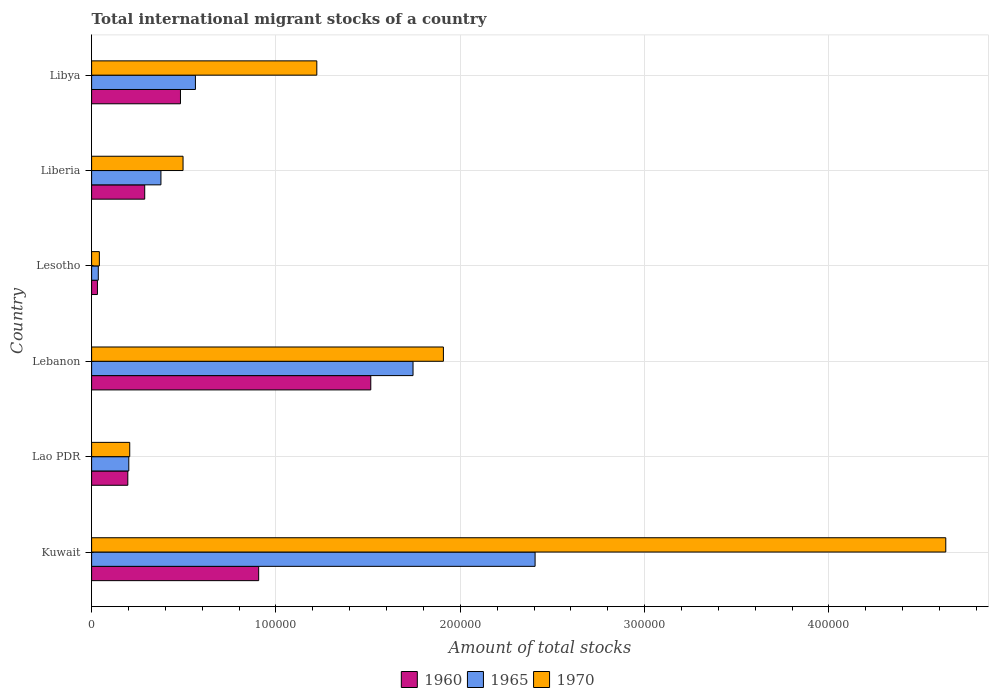How many bars are there on the 6th tick from the bottom?
Your answer should be compact. 3. What is the label of the 4th group of bars from the top?
Your response must be concise. Lebanon. What is the amount of total stocks in in 1965 in Liberia?
Give a very brief answer. 3.76e+04. Across all countries, what is the maximum amount of total stocks in in 1965?
Offer a terse response. 2.41e+05. Across all countries, what is the minimum amount of total stocks in in 1970?
Your answer should be very brief. 4205. In which country was the amount of total stocks in in 1960 maximum?
Your answer should be compact. Lebanon. In which country was the amount of total stocks in in 1960 minimum?
Give a very brief answer. Lesotho. What is the total amount of total stocks in in 1965 in the graph?
Offer a terse response. 5.33e+05. What is the difference between the amount of total stocks in in 1960 in Kuwait and that in Libya?
Your answer should be very brief. 4.24e+04. What is the difference between the amount of total stocks in in 1970 in Lesotho and the amount of total stocks in in 1960 in Kuwait?
Give a very brief answer. -8.64e+04. What is the average amount of total stocks in in 1965 per country?
Offer a terse response. 8.88e+04. What is the difference between the amount of total stocks in in 1960 and amount of total stocks in in 1965 in Lebanon?
Your response must be concise. -2.29e+04. In how many countries, is the amount of total stocks in in 1970 greater than 340000 ?
Make the answer very short. 1. What is the ratio of the amount of total stocks in in 1960 in Lebanon to that in Liberia?
Offer a very short reply. 5.26. Is the amount of total stocks in in 1965 in Lao PDR less than that in Lebanon?
Give a very brief answer. Yes. Is the difference between the amount of total stocks in in 1960 in Lao PDR and Lesotho greater than the difference between the amount of total stocks in in 1965 in Lao PDR and Lesotho?
Offer a very short reply. No. What is the difference between the highest and the second highest amount of total stocks in in 1970?
Your answer should be compact. 2.73e+05. What is the difference between the highest and the lowest amount of total stocks in in 1960?
Give a very brief answer. 1.48e+05. Is the sum of the amount of total stocks in in 1965 in Lao PDR and Liberia greater than the maximum amount of total stocks in in 1970 across all countries?
Give a very brief answer. No. What does the 1st bar from the top in Lao PDR represents?
Offer a terse response. 1970. What does the 1st bar from the bottom in Kuwait represents?
Offer a very short reply. 1960. Are all the bars in the graph horizontal?
Give a very brief answer. Yes. How many countries are there in the graph?
Provide a short and direct response. 6. Are the values on the major ticks of X-axis written in scientific E-notation?
Provide a succinct answer. No. Does the graph contain any zero values?
Offer a terse response. No. Does the graph contain grids?
Your answer should be very brief. Yes. Where does the legend appear in the graph?
Your answer should be compact. Bottom center. How many legend labels are there?
Keep it short and to the point. 3. What is the title of the graph?
Offer a very short reply. Total international migrant stocks of a country. What is the label or title of the X-axis?
Offer a very short reply. Amount of total stocks. What is the Amount of total stocks of 1960 in Kuwait?
Offer a very short reply. 9.06e+04. What is the Amount of total stocks of 1965 in Kuwait?
Your response must be concise. 2.41e+05. What is the Amount of total stocks in 1970 in Kuwait?
Your answer should be very brief. 4.63e+05. What is the Amount of total stocks of 1960 in Lao PDR?
Offer a very short reply. 1.96e+04. What is the Amount of total stocks in 1965 in Lao PDR?
Your answer should be compact. 2.02e+04. What is the Amount of total stocks in 1970 in Lao PDR?
Your answer should be very brief. 2.07e+04. What is the Amount of total stocks of 1960 in Lebanon?
Keep it short and to the point. 1.51e+05. What is the Amount of total stocks of 1965 in Lebanon?
Offer a very short reply. 1.74e+05. What is the Amount of total stocks in 1970 in Lebanon?
Make the answer very short. 1.91e+05. What is the Amount of total stocks of 1960 in Lesotho?
Give a very brief answer. 3165. What is the Amount of total stocks of 1965 in Lesotho?
Make the answer very short. 3633. What is the Amount of total stocks in 1970 in Lesotho?
Offer a terse response. 4205. What is the Amount of total stocks of 1960 in Liberia?
Offer a terse response. 2.88e+04. What is the Amount of total stocks of 1965 in Liberia?
Your response must be concise. 3.76e+04. What is the Amount of total stocks in 1970 in Liberia?
Give a very brief answer. 4.96e+04. What is the Amount of total stocks in 1960 in Libya?
Provide a succinct answer. 4.82e+04. What is the Amount of total stocks of 1965 in Libya?
Your answer should be compact. 5.63e+04. What is the Amount of total stocks of 1970 in Libya?
Your response must be concise. 1.22e+05. Across all countries, what is the maximum Amount of total stocks in 1960?
Make the answer very short. 1.51e+05. Across all countries, what is the maximum Amount of total stocks in 1965?
Offer a terse response. 2.41e+05. Across all countries, what is the maximum Amount of total stocks of 1970?
Provide a succinct answer. 4.63e+05. Across all countries, what is the minimum Amount of total stocks of 1960?
Provide a short and direct response. 3165. Across all countries, what is the minimum Amount of total stocks in 1965?
Provide a succinct answer. 3633. Across all countries, what is the minimum Amount of total stocks of 1970?
Ensure brevity in your answer.  4205. What is the total Amount of total stocks of 1960 in the graph?
Make the answer very short. 3.42e+05. What is the total Amount of total stocks in 1965 in the graph?
Offer a terse response. 5.33e+05. What is the total Amount of total stocks of 1970 in the graph?
Ensure brevity in your answer.  8.51e+05. What is the difference between the Amount of total stocks in 1960 in Kuwait and that in Lao PDR?
Your answer should be very brief. 7.10e+04. What is the difference between the Amount of total stocks in 1965 in Kuwait and that in Lao PDR?
Provide a short and direct response. 2.20e+05. What is the difference between the Amount of total stocks in 1970 in Kuwait and that in Lao PDR?
Your response must be concise. 4.43e+05. What is the difference between the Amount of total stocks in 1960 in Kuwait and that in Lebanon?
Make the answer very short. -6.08e+04. What is the difference between the Amount of total stocks of 1965 in Kuwait and that in Lebanon?
Make the answer very short. 6.62e+04. What is the difference between the Amount of total stocks in 1970 in Kuwait and that in Lebanon?
Offer a terse response. 2.73e+05. What is the difference between the Amount of total stocks in 1960 in Kuwait and that in Lesotho?
Provide a short and direct response. 8.75e+04. What is the difference between the Amount of total stocks of 1965 in Kuwait and that in Lesotho?
Your answer should be compact. 2.37e+05. What is the difference between the Amount of total stocks of 1970 in Kuwait and that in Lesotho?
Your response must be concise. 4.59e+05. What is the difference between the Amount of total stocks of 1960 in Kuwait and that in Liberia?
Give a very brief answer. 6.18e+04. What is the difference between the Amount of total stocks in 1965 in Kuwait and that in Liberia?
Provide a succinct answer. 2.03e+05. What is the difference between the Amount of total stocks of 1970 in Kuwait and that in Liberia?
Offer a very short reply. 4.14e+05. What is the difference between the Amount of total stocks of 1960 in Kuwait and that in Libya?
Your answer should be very brief. 4.24e+04. What is the difference between the Amount of total stocks in 1965 in Kuwait and that in Libya?
Give a very brief answer. 1.84e+05. What is the difference between the Amount of total stocks in 1970 in Kuwait and that in Libya?
Your answer should be compact. 3.41e+05. What is the difference between the Amount of total stocks of 1960 in Lao PDR and that in Lebanon?
Keep it short and to the point. -1.32e+05. What is the difference between the Amount of total stocks of 1965 in Lao PDR and that in Lebanon?
Your answer should be compact. -1.54e+05. What is the difference between the Amount of total stocks of 1970 in Lao PDR and that in Lebanon?
Ensure brevity in your answer.  -1.70e+05. What is the difference between the Amount of total stocks of 1960 in Lao PDR and that in Lesotho?
Offer a terse response. 1.65e+04. What is the difference between the Amount of total stocks in 1965 in Lao PDR and that in Lesotho?
Ensure brevity in your answer.  1.65e+04. What is the difference between the Amount of total stocks of 1970 in Lao PDR and that in Lesotho?
Your response must be concise. 1.65e+04. What is the difference between the Amount of total stocks of 1960 in Lao PDR and that in Liberia?
Provide a succinct answer. -9165. What is the difference between the Amount of total stocks of 1965 in Lao PDR and that in Liberia?
Provide a short and direct response. -1.74e+04. What is the difference between the Amount of total stocks in 1970 in Lao PDR and that in Liberia?
Your answer should be compact. -2.89e+04. What is the difference between the Amount of total stocks of 1960 in Lao PDR and that in Libya?
Make the answer very short. -2.86e+04. What is the difference between the Amount of total stocks in 1965 in Lao PDR and that in Libya?
Your answer should be compact. -3.61e+04. What is the difference between the Amount of total stocks of 1970 in Lao PDR and that in Libya?
Make the answer very short. -1.01e+05. What is the difference between the Amount of total stocks of 1960 in Lebanon and that in Lesotho?
Ensure brevity in your answer.  1.48e+05. What is the difference between the Amount of total stocks in 1965 in Lebanon and that in Lesotho?
Provide a short and direct response. 1.71e+05. What is the difference between the Amount of total stocks of 1970 in Lebanon and that in Lesotho?
Make the answer very short. 1.87e+05. What is the difference between the Amount of total stocks of 1960 in Lebanon and that in Liberia?
Offer a very short reply. 1.23e+05. What is the difference between the Amount of total stocks in 1965 in Lebanon and that in Liberia?
Your response must be concise. 1.37e+05. What is the difference between the Amount of total stocks in 1970 in Lebanon and that in Liberia?
Your answer should be compact. 1.41e+05. What is the difference between the Amount of total stocks of 1960 in Lebanon and that in Libya?
Your answer should be very brief. 1.03e+05. What is the difference between the Amount of total stocks of 1965 in Lebanon and that in Libya?
Your answer should be very brief. 1.18e+05. What is the difference between the Amount of total stocks in 1970 in Lebanon and that in Libya?
Provide a short and direct response. 6.87e+04. What is the difference between the Amount of total stocks in 1960 in Lesotho and that in Liberia?
Offer a very short reply. -2.56e+04. What is the difference between the Amount of total stocks of 1965 in Lesotho and that in Liberia?
Your answer should be very brief. -3.40e+04. What is the difference between the Amount of total stocks in 1970 in Lesotho and that in Liberia?
Make the answer very short. -4.54e+04. What is the difference between the Amount of total stocks in 1960 in Lesotho and that in Libya?
Keep it short and to the point. -4.50e+04. What is the difference between the Amount of total stocks of 1965 in Lesotho and that in Libya?
Ensure brevity in your answer.  -5.27e+04. What is the difference between the Amount of total stocks of 1970 in Lesotho and that in Libya?
Ensure brevity in your answer.  -1.18e+05. What is the difference between the Amount of total stocks in 1960 in Liberia and that in Libya?
Provide a short and direct response. -1.94e+04. What is the difference between the Amount of total stocks in 1965 in Liberia and that in Libya?
Your answer should be very brief. -1.87e+04. What is the difference between the Amount of total stocks of 1970 in Liberia and that in Libya?
Provide a succinct answer. -7.26e+04. What is the difference between the Amount of total stocks in 1960 in Kuwait and the Amount of total stocks in 1965 in Lao PDR?
Provide a short and direct response. 7.05e+04. What is the difference between the Amount of total stocks in 1960 in Kuwait and the Amount of total stocks in 1970 in Lao PDR?
Provide a short and direct response. 6.99e+04. What is the difference between the Amount of total stocks of 1965 in Kuwait and the Amount of total stocks of 1970 in Lao PDR?
Your answer should be compact. 2.20e+05. What is the difference between the Amount of total stocks in 1960 in Kuwait and the Amount of total stocks in 1965 in Lebanon?
Keep it short and to the point. -8.37e+04. What is the difference between the Amount of total stocks of 1960 in Kuwait and the Amount of total stocks of 1970 in Lebanon?
Offer a terse response. -1.00e+05. What is the difference between the Amount of total stocks in 1965 in Kuwait and the Amount of total stocks in 1970 in Lebanon?
Keep it short and to the point. 4.97e+04. What is the difference between the Amount of total stocks in 1960 in Kuwait and the Amount of total stocks in 1965 in Lesotho?
Give a very brief answer. 8.70e+04. What is the difference between the Amount of total stocks of 1960 in Kuwait and the Amount of total stocks of 1970 in Lesotho?
Provide a short and direct response. 8.64e+04. What is the difference between the Amount of total stocks in 1965 in Kuwait and the Amount of total stocks in 1970 in Lesotho?
Provide a succinct answer. 2.36e+05. What is the difference between the Amount of total stocks in 1960 in Kuwait and the Amount of total stocks in 1965 in Liberia?
Give a very brief answer. 5.30e+04. What is the difference between the Amount of total stocks of 1960 in Kuwait and the Amount of total stocks of 1970 in Liberia?
Your answer should be compact. 4.10e+04. What is the difference between the Amount of total stocks of 1965 in Kuwait and the Amount of total stocks of 1970 in Liberia?
Ensure brevity in your answer.  1.91e+05. What is the difference between the Amount of total stocks of 1960 in Kuwait and the Amount of total stocks of 1965 in Libya?
Ensure brevity in your answer.  3.43e+04. What is the difference between the Amount of total stocks of 1960 in Kuwait and the Amount of total stocks of 1970 in Libya?
Offer a very short reply. -3.15e+04. What is the difference between the Amount of total stocks of 1965 in Kuwait and the Amount of total stocks of 1970 in Libya?
Make the answer very short. 1.18e+05. What is the difference between the Amount of total stocks in 1960 in Lao PDR and the Amount of total stocks in 1965 in Lebanon?
Offer a very short reply. -1.55e+05. What is the difference between the Amount of total stocks of 1960 in Lao PDR and the Amount of total stocks of 1970 in Lebanon?
Provide a short and direct response. -1.71e+05. What is the difference between the Amount of total stocks in 1965 in Lao PDR and the Amount of total stocks in 1970 in Lebanon?
Give a very brief answer. -1.71e+05. What is the difference between the Amount of total stocks in 1960 in Lao PDR and the Amount of total stocks in 1965 in Lesotho?
Make the answer very short. 1.60e+04. What is the difference between the Amount of total stocks of 1960 in Lao PDR and the Amount of total stocks of 1970 in Lesotho?
Ensure brevity in your answer.  1.54e+04. What is the difference between the Amount of total stocks of 1965 in Lao PDR and the Amount of total stocks of 1970 in Lesotho?
Offer a very short reply. 1.60e+04. What is the difference between the Amount of total stocks of 1960 in Lao PDR and the Amount of total stocks of 1965 in Liberia?
Make the answer very short. -1.80e+04. What is the difference between the Amount of total stocks in 1960 in Lao PDR and the Amount of total stocks in 1970 in Liberia?
Provide a short and direct response. -3.00e+04. What is the difference between the Amount of total stocks of 1965 in Lao PDR and the Amount of total stocks of 1970 in Liberia?
Provide a short and direct response. -2.94e+04. What is the difference between the Amount of total stocks of 1960 in Lao PDR and the Amount of total stocks of 1965 in Libya?
Your answer should be very brief. -3.67e+04. What is the difference between the Amount of total stocks in 1960 in Lao PDR and the Amount of total stocks in 1970 in Libya?
Offer a very short reply. -1.03e+05. What is the difference between the Amount of total stocks of 1965 in Lao PDR and the Amount of total stocks of 1970 in Libya?
Give a very brief answer. -1.02e+05. What is the difference between the Amount of total stocks of 1960 in Lebanon and the Amount of total stocks of 1965 in Lesotho?
Provide a succinct answer. 1.48e+05. What is the difference between the Amount of total stocks of 1960 in Lebanon and the Amount of total stocks of 1970 in Lesotho?
Offer a very short reply. 1.47e+05. What is the difference between the Amount of total stocks in 1965 in Lebanon and the Amount of total stocks in 1970 in Lesotho?
Ensure brevity in your answer.  1.70e+05. What is the difference between the Amount of total stocks in 1960 in Lebanon and the Amount of total stocks in 1965 in Liberia?
Your answer should be very brief. 1.14e+05. What is the difference between the Amount of total stocks of 1960 in Lebanon and the Amount of total stocks of 1970 in Liberia?
Make the answer very short. 1.02e+05. What is the difference between the Amount of total stocks of 1965 in Lebanon and the Amount of total stocks of 1970 in Liberia?
Offer a very short reply. 1.25e+05. What is the difference between the Amount of total stocks in 1960 in Lebanon and the Amount of total stocks in 1965 in Libya?
Keep it short and to the point. 9.51e+04. What is the difference between the Amount of total stocks in 1960 in Lebanon and the Amount of total stocks in 1970 in Libya?
Your answer should be compact. 2.93e+04. What is the difference between the Amount of total stocks of 1965 in Lebanon and the Amount of total stocks of 1970 in Libya?
Your answer should be compact. 5.22e+04. What is the difference between the Amount of total stocks of 1960 in Lesotho and the Amount of total stocks of 1965 in Liberia?
Keep it short and to the point. -3.44e+04. What is the difference between the Amount of total stocks of 1960 in Lesotho and the Amount of total stocks of 1970 in Liberia?
Make the answer very short. -4.64e+04. What is the difference between the Amount of total stocks in 1965 in Lesotho and the Amount of total stocks in 1970 in Liberia?
Your response must be concise. -4.60e+04. What is the difference between the Amount of total stocks of 1960 in Lesotho and the Amount of total stocks of 1965 in Libya?
Give a very brief answer. -5.32e+04. What is the difference between the Amount of total stocks of 1960 in Lesotho and the Amount of total stocks of 1970 in Libya?
Offer a very short reply. -1.19e+05. What is the difference between the Amount of total stocks in 1965 in Lesotho and the Amount of total stocks in 1970 in Libya?
Give a very brief answer. -1.19e+05. What is the difference between the Amount of total stocks of 1960 in Liberia and the Amount of total stocks of 1965 in Libya?
Make the answer very short. -2.75e+04. What is the difference between the Amount of total stocks in 1960 in Liberia and the Amount of total stocks in 1970 in Libya?
Make the answer very short. -9.34e+04. What is the difference between the Amount of total stocks of 1965 in Liberia and the Amount of total stocks of 1970 in Libya?
Your response must be concise. -8.46e+04. What is the average Amount of total stocks of 1960 per country?
Provide a short and direct response. 5.70e+04. What is the average Amount of total stocks in 1965 per country?
Make the answer very short. 8.88e+04. What is the average Amount of total stocks in 1970 per country?
Make the answer very short. 1.42e+05. What is the difference between the Amount of total stocks of 1960 and Amount of total stocks of 1965 in Kuwait?
Provide a succinct answer. -1.50e+05. What is the difference between the Amount of total stocks in 1960 and Amount of total stocks in 1970 in Kuwait?
Make the answer very short. -3.73e+05. What is the difference between the Amount of total stocks in 1965 and Amount of total stocks in 1970 in Kuwait?
Provide a short and direct response. -2.23e+05. What is the difference between the Amount of total stocks of 1960 and Amount of total stocks of 1965 in Lao PDR?
Provide a short and direct response. -531. What is the difference between the Amount of total stocks in 1960 and Amount of total stocks in 1970 in Lao PDR?
Your answer should be very brief. -1042. What is the difference between the Amount of total stocks in 1965 and Amount of total stocks in 1970 in Lao PDR?
Make the answer very short. -511. What is the difference between the Amount of total stocks in 1960 and Amount of total stocks in 1965 in Lebanon?
Ensure brevity in your answer.  -2.29e+04. What is the difference between the Amount of total stocks of 1960 and Amount of total stocks of 1970 in Lebanon?
Give a very brief answer. -3.94e+04. What is the difference between the Amount of total stocks in 1965 and Amount of total stocks in 1970 in Lebanon?
Give a very brief answer. -1.65e+04. What is the difference between the Amount of total stocks of 1960 and Amount of total stocks of 1965 in Lesotho?
Provide a succinct answer. -468. What is the difference between the Amount of total stocks in 1960 and Amount of total stocks in 1970 in Lesotho?
Ensure brevity in your answer.  -1040. What is the difference between the Amount of total stocks of 1965 and Amount of total stocks of 1970 in Lesotho?
Give a very brief answer. -572. What is the difference between the Amount of total stocks of 1960 and Amount of total stocks of 1965 in Liberia?
Provide a short and direct response. -8803. What is the difference between the Amount of total stocks in 1960 and Amount of total stocks in 1970 in Liberia?
Your answer should be very brief. -2.08e+04. What is the difference between the Amount of total stocks of 1965 and Amount of total stocks of 1970 in Liberia?
Your answer should be compact. -1.20e+04. What is the difference between the Amount of total stocks in 1960 and Amount of total stocks in 1965 in Libya?
Offer a very short reply. -8110. What is the difference between the Amount of total stocks in 1960 and Amount of total stocks in 1970 in Libya?
Offer a terse response. -7.40e+04. What is the difference between the Amount of total stocks in 1965 and Amount of total stocks in 1970 in Libya?
Provide a succinct answer. -6.58e+04. What is the ratio of the Amount of total stocks of 1960 in Kuwait to that in Lao PDR?
Your answer should be compact. 4.61. What is the ratio of the Amount of total stocks of 1965 in Kuwait to that in Lao PDR?
Make the answer very short. 11.92. What is the ratio of the Amount of total stocks of 1970 in Kuwait to that in Lao PDR?
Give a very brief answer. 22.4. What is the ratio of the Amount of total stocks in 1960 in Kuwait to that in Lebanon?
Provide a succinct answer. 0.6. What is the ratio of the Amount of total stocks of 1965 in Kuwait to that in Lebanon?
Give a very brief answer. 1.38. What is the ratio of the Amount of total stocks of 1970 in Kuwait to that in Lebanon?
Keep it short and to the point. 2.43. What is the ratio of the Amount of total stocks in 1960 in Kuwait to that in Lesotho?
Keep it short and to the point. 28.63. What is the ratio of the Amount of total stocks of 1965 in Kuwait to that in Lesotho?
Provide a succinct answer. 66.22. What is the ratio of the Amount of total stocks in 1970 in Kuwait to that in Lesotho?
Keep it short and to the point. 110.19. What is the ratio of the Amount of total stocks of 1960 in Kuwait to that in Liberia?
Provide a succinct answer. 3.15. What is the ratio of the Amount of total stocks in 1965 in Kuwait to that in Liberia?
Offer a very short reply. 6.4. What is the ratio of the Amount of total stocks in 1970 in Kuwait to that in Liberia?
Make the answer very short. 9.34. What is the ratio of the Amount of total stocks in 1960 in Kuwait to that in Libya?
Make the answer very short. 1.88. What is the ratio of the Amount of total stocks of 1965 in Kuwait to that in Libya?
Provide a succinct answer. 4.27. What is the ratio of the Amount of total stocks of 1970 in Kuwait to that in Libya?
Ensure brevity in your answer.  3.79. What is the ratio of the Amount of total stocks of 1960 in Lao PDR to that in Lebanon?
Provide a short and direct response. 0.13. What is the ratio of the Amount of total stocks in 1965 in Lao PDR to that in Lebanon?
Offer a very short reply. 0.12. What is the ratio of the Amount of total stocks in 1970 in Lao PDR to that in Lebanon?
Your answer should be very brief. 0.11. What is the ratio of the Amount of total stocks in 1960 in Lao PDR to that in Lesotho?
Ensure brevity in your answer.  6.21. What is the ratio of the Amount of total stocks of 1965 in Lao PDR to that in Lesotho?
Ensure brevity in your answer.  5.55. What is the ratio of the Amount of total stocks in 1970 in Lao PDR to that in Lesotho?
Offer a terse response. 4.92. What is the ratio of the Amount of total stocks of 1960 in Lao PDR to that in Liberia?
Provide a succinct answer. 0.68. What is the ratio of the Amount of total stocks in 1965 in Lao PDR to that in Liberia?
Give a very brief answer. 0.54. What is the ratio of the Amount of total stocks in 1970 in Lao PDR to that in Liberia?
Your answer should be very brief. 0.42. What is the ratio of the Amount of total stocks in 1960 in Lao PDR to that in Libya?
Ensure brevity in your answer.  0.41. What is the ratio of the Amount of total stocks of 1965 in Lao PDR to that in Libya?
Your response must be concise. 0.36. What is the ratio of the Amount of total stocks in 1970 in Lao PDR to that in Libya?
Ensure brevity in your answer.  0.17. What is the ratio of the Amount of total stocks of 1960 in Lebanon to that in Lesotho?
Provide a succinct answer. 47.85. What is the ratio of the Amount of total stocks of 1965 in Lebanon to that in Lesotho?
Ensure brevity in your answer.  48. What is the ratio of the Amount of total stocks of 1970 in Lebanon to that in Lesotho?
Provide a succinct answer. 45.38. What is the ratio of the Amount of total stocks of 1960 in Lebanon to that in Liberia?
Make the answer very short. 5.26. What is the ratio of the Amount of total stocks of 1965 in Lebanon to that in Liberia?
Make the answer very short. 4.64. What is the ratio of the Amount of total stocks of 1970 in Lebanon to that in Liberia?
Offer a very short reply. 3.85. What is the ratio of the Amount of total stocks of 1960 in Lebanon to that in Libya?
Offer a terse response. 3.14. What is the ratio of the Amount of total stocks in 1965 in Lebanon to that in Libya?
Your answer should be compact. 3.1. What is the ratio of the Amount of total stocks of 1970 in Lebanon to that in Libya?
Provide a succinct answer. 1.56. What is the ratio of the Amount of total stocks in 1960 in Lesotho to that in Liberia?
Ensure brevity in your answer.  0.11. What is the ratio of the Amount of total stocks in 1965 in Lesotho to that in Liberia?
Offer a very short reply. 0.1. What is the ratio of the Amount of total stocks of 1970 in Lesotho to that in Liberia?
Provide a short and direct response. 0.08. What is the ratio of the Amount of total stocks of 1960 in Lesotho to that in Libya?
Give a very brief answer. 0.07. What is the ratio of the Amount of total stocks in 1965 in Lesotho to that in Libya?
Make the answer very short. 0.06. What is the ratio of the Amount of total stocks of 1970 in Lesotho to that in Libya?
Give a very brief answer. 0.03. What is the ratio of the Amount of total stocks in 1960 in Liberia to that in Libya?
Your answer should be compact. 0.6. What is the ratio of the Amount of total stocks in 1965 in Liberia to that in Libya?
Offer a terse response. 0.67. What is the ratio of the Amount of total stocks of 1970 in Liberia to that in Libya?
Your answer should be compact. 0.41. What is the difference between the highest and the second highest Amount of total stocks in 1960?
Your answer should be very brief. 6.08e+04. What is the difference between the highest and the second highest Amount of total stocks of 1965?
Offer a terse response. 6.62e+04. What is the difference between the highest and the second highest Amount of total stocks in 1970?
Offer a very short reply. 2.73e+05. What is the difference between the highest and the lowest Amount of total stocks of 1960?
Keep it short and to the point. 1.48e+05. What is the difference between the highest and the lowest Amount of total stocks in 1965?
Provide a short and direct response. 2.37e+05. What is the difference between the highest and the lowest Amount of total stocks in 1970?
Offer a very short reply. 4.59e+05. 